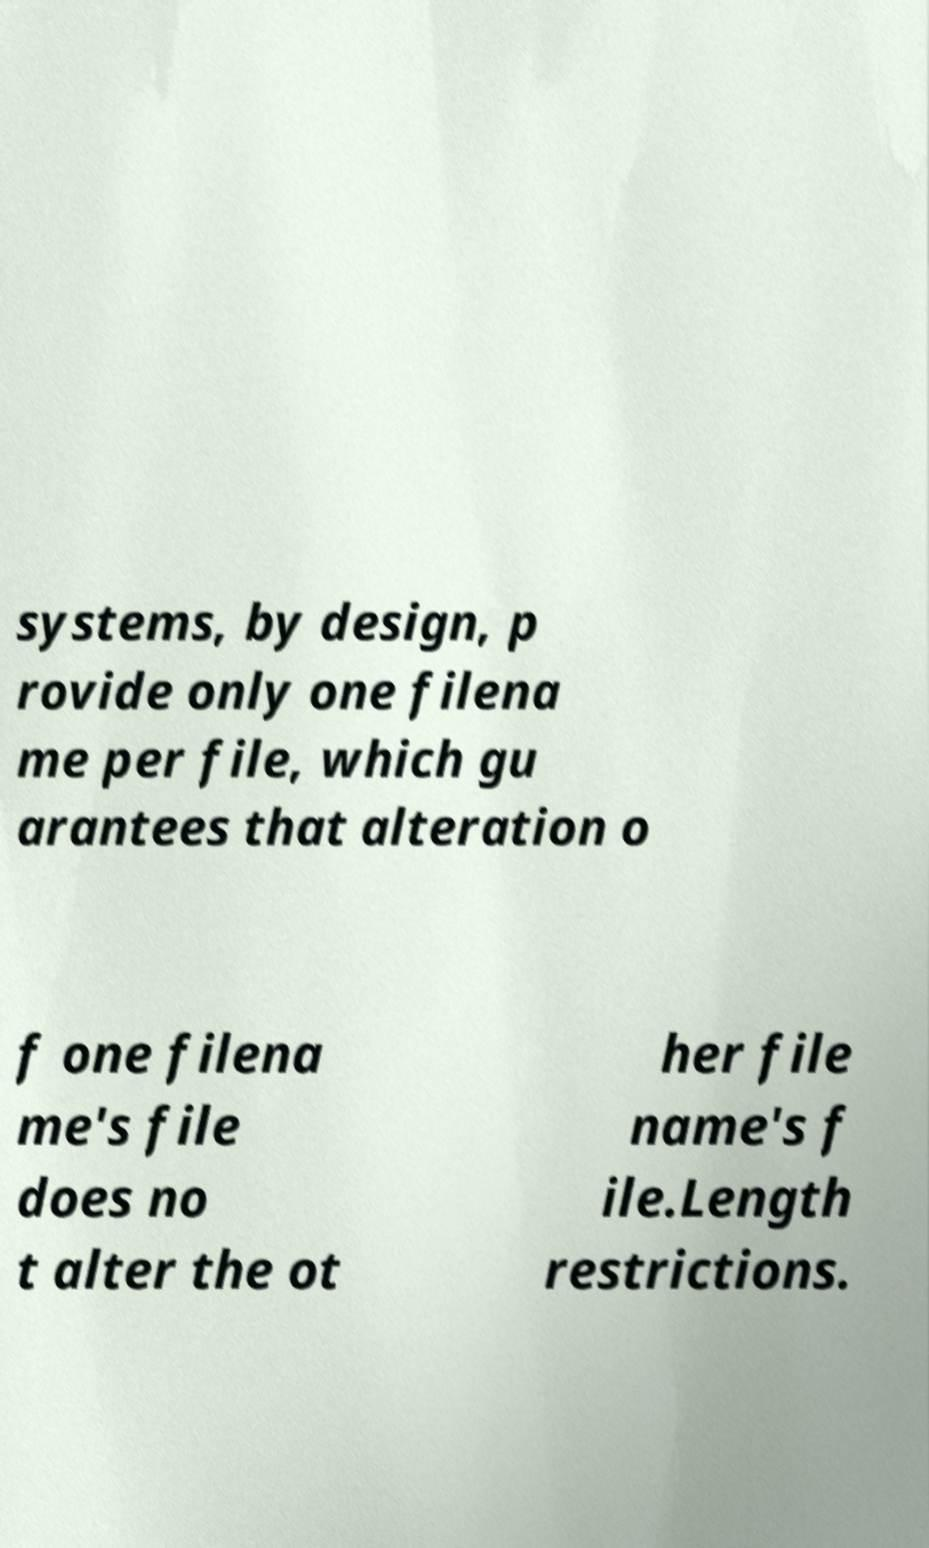Can you accurately transcribe the text from the provided image for me? systems, by design, p rovide only one filena me per file, which gu arantees that alteration o f one filena me's file does no t alter the ot her file name's f ile.Length restrictions. 